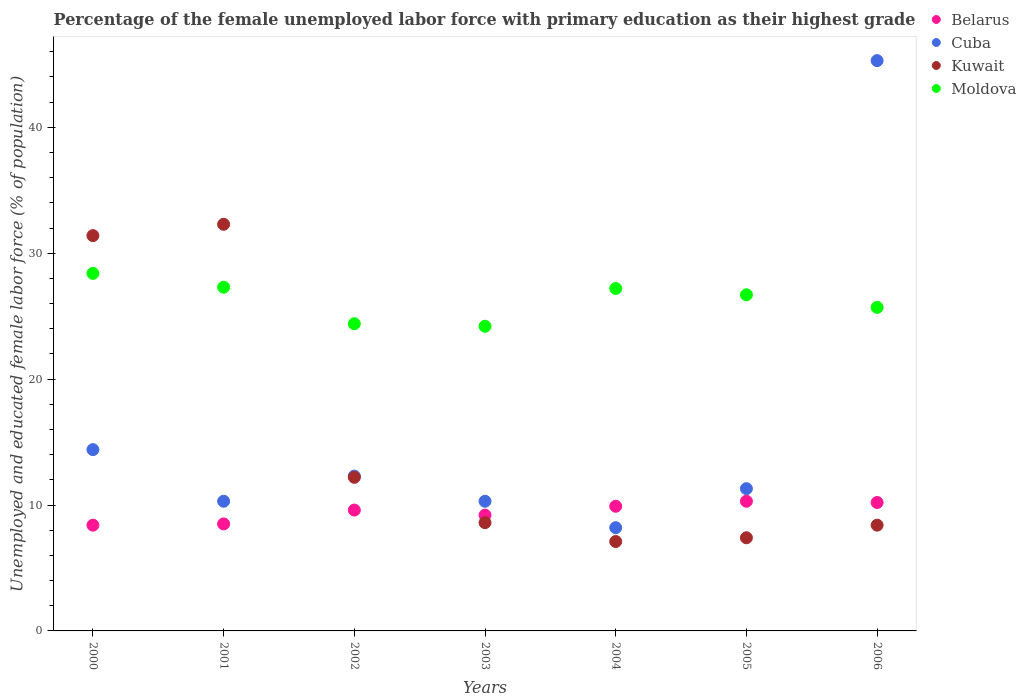How many different coloured dotlines are there?
Make the answer very short. 4. What is the percentage of the unemployed female labor force with primary education in Moldova in 2006?
Keep it short and to the point. 25.7. Across all years, what is the maximum percentage of the unemployed female labor force with primary education in Belarus?
Ensure brevity in your answer.  10.3. Across all years, what is the minimum percentage of the unemployed female labor force with primary education in Moldova?
Ensure brevity in your answer.  24.2. What is the total percentage of the unemployed female labor force with primary education in Belarus in the graph?
Ensure brevity in your answer.  66.1. What is the difference between the percentage of the unemployed female labor force with primary education in Kuwait in 2003 and that in 2004?
Ensure brevity in your answer.  1.5. What is the difference between the percentage of the unemployed female labor force with primary education in Kuwait in 2001 and the percentage of the unemployed female labor force with primary education in Belarus in 2000?
Keep it short and to the point. 23.9. What is the average percentage of the unemployed female labor force with primary education in Belarus per year?
Provide a short and direct response. 9.44. In the year 2006, what is the difference between the percentage of the unemployed female labor force with primary education in Kuwait and percentage of the unemployed female labor force with primary education in Moldova?
Your response must be concise. -17.3. What is the ratio of the percentage of the unemployed female labor force with primary education in Belarus in 2000 to that in 2002?
Your answer should be very brief. 0.87. What is the difference between the highest and the second highest percentage of the unemployed female labor force with primary education in Kuwait?
Ensure brevity in your answer.  0.9. What is the difference between the highest and the lowest percentage of the unemployed female labor force with primary education in Cuba?
Keep it short and to the point. 37.1. In how many years, is the percentage of the unemployed female labor force with primary education in Belarus greater than the average percentage of the unemployed female labor force with primary education in Belarus taken over all years?
Provide a short and direct response. 4. Does the percentage of the unemployed female labor force with primary education in Cuba monotonically increase over the years?
Make the answer very short. No. Is the percentage of the unemployed female labor force with primary education in Cuba strictly greater than the percentage of the unemployed female labor force with primary education in Moldova over the years?
Provide a succinct answer. No. Is the percentage of the unemployed female labor force with primary education in Belarus strictly less than the percentage of the unemployed female labor force with primary education in Moldova over the years?
Provide a succinct answer. Yes. How many dotlines are there?
Keep it short and to the point. 4. How many legend labels are there?
Your answer should be compact. 4. How are the legend labels stacked?
Ensure brevity in your answer.  Vertical. What is the title of the graph?
Provide a short and direct response. Percentage of the female unemployed labor force with primary education as their highest grade. Does "Mauritania" appear as one of the legend labels in the graph?
Give a very brief answer. No. What is the label or title of the X-axis?
Keep it short and to the point. Years. What is the label or title of the Y-axis?
Offer a terse response. Unemployed and educated female labor force (% of population). What is the Unemployed and educated female labor force (% of population) in Belarus in 2000?
Your answer should be very brief. 8.4. What is the Unemployed and educated female labor force (% of population) of Cuba in 2000?
Offer a very short reply. 14.4. What is the Unemployed and educated female labor force (% of population) in Kuwait in 2000?
Give a very brief answer. 31.4. What is the Unemployed and educated female labor force (% of population) in Moldova in 2000?
Ensure brevity in your answer.  28.4. What is the Unemployed and educated female labor force (% of population) in Cuba in 2001?
Provide a succinct answer. 10.3. What is the Unemployed and educated female labor force (% of population) of Kuwait in 2001?
Make the answer very short. 32.3. What is the Unemployed and educated female labor force (% of population) of Moldova in 2001?
Provide a short and direct response. 27.3. What is the Unemployed and educated female labor force (% of population) in Belarus in 2002?
Offer a terse response. 9.6. What is the Unemployed and educated female labor force (% of population) of Cuba in 2002?
Your response must be concise. 12.3. What is the Unemployed and educated female labor force (% of population) of Kuwait in 2002?
Your response must be concise. 12.2. What is the Unemployed and educated female labor force (% of population) in Moldova in 2002?
Keep it short and to the point. 24.4. What is the Unemployed and educated female labor force (% of population) of Belarus in 2003?
Offer a terse response. 9.2. What is the Unemployed and educated female labor force (% of population) of Cuba in 2003?
Your answer should be compact. 10.3. What is the Unemployed and educated female labor force (% of population) of Kuwait in 2003?
Offer a very short reply. 8.6. What is the Unemployed and educated female labor force (% of population) in Moldova in 2003?
Make the answer very short. 24.2. What is the Unemployed and educated female labor force (% of population) in Belarus in 2004?
Provide a succinct answer. 9.9. What is the Unemployed and educated female labor force (% of population) in Cuba in 2004?
Your answer should be compact. 8.2. What is the Unemployed and educated female labor force (% of population) in Kuwait in 2004?
Your answer should be compact. 7.1. What is the Unemployed and educated female labor force (% of population) of Moldova in 2004?
Ensure brevity in your answer.  27.2. What is the Unemployed and educated female labor force (% of population) in Belarus in 2005?
Offer a terse response. 10.3. What is the Unemployed and educated female labor force (% of population) of Cuba in 2005?
Ensure brevity in your answer.  11.3. What is the Unemployed and educated female labor force (% of population) in Kuwait in 2005?
Your answer should be compact. 7.4. What is the Unemployed and educated female labor force (% of population) of Moldova in 2005?
Your answer should be very brief. 26.7. What is the Unemployed and educated female labor force (% of population) in Belarus in 2006?
Offer a terse response. 10.2. What is the Unemployed and educated female labor force (% of population) of Cuba in 2006?
Make the answer very short. 45.3. What is the Unemployed and educated female labor force (% of population) of Kuwait in 2006?
Offer a very short reply. 8.4. What is the Unemployed and educated female labor force (% of population) of Moldova in 2006?
Provide a succinct answer. 25.7. Across all years, what is the maximum Unemployed and educated female labor force (% of population) of Belarus?
Your answer should be very brief. 10.3. Across all years, what is the maximum Unemployed and educated female labor force (% of population) in Cuba?
Make the answer very short. 45.3. Across all years, what is the maximum Unemployed and educated female labor force (% of population) in Kuwait?
Provide a short and direct response. 32.3. Across all years, what is the maximum Unemployed and educated female labor force (% of population) in Moldova?
Ensure brevity in your answer.  28.4. Across all years, what is the minimum Unemployed and educated female labor force (% of population) of Belarus?
Your answer should be compact. 8.4. Across all years, what is the minimum Unemployed and educated female labor force (% of population) in Cuba?
Your answer should be very brief. 8.2. Across all years, what is the minimum Unemployed and educated female labor force (% of population) of Kuwait?
Offer a terse response. 7.1. Across all years, what is the minimum Unemployed and educated female labor force (% of population) of Moldova?
Give a very brief answer. 24.2. What is the total Unemployed and educated female labor force (% of population) of Belarus in the graph?
Make the answer very short. 66.1. What is the total Unemployed and educated female labor force (% of population) of Cuba in the graph?
Provide a succinct answer. 112.1. What is the total Unemployed and educated female labor force (% of population) in Kuwait in the graph?
Ensure brevity in your answer.  107.4. What is the total Unemployed and educated female labor force (% of population) in Moldova in the graph?
Make the answer very short. 183.9. What is the difference between the Unemployed and educated female labor force (% of population) in Kuwait in 2000 and that in 2001?
Make the answer very short. -0.9. What is the difference between the Unemployed and educated female labor force (% of population) in Cuba in 2000 and that in 2002?
Keep it short and to the point. 2.1. What is the difference between the Unemployed and educated female labor force (% of population) in Moldova in 2000 and that in 2002?
Keep it short and to the point. 4. What is the difference between the Unemployed and educated female labor force (% of population) of Belarus in 2000 and that in 2003?
Keep it short and to the point. -0.8. What is the difference between the Unemployed and educated female labor force (% of population) of Kuwait in 2000 and that in 2003?
Your answer should be compact. 22.8. What is the difference between the Unemployed and educated female labor force (% of population) in Cuba in 2000 and that in 2004?
Provide a short and direct response. 6.2. What is the difference between the Unemployed and educated female labor force (% of population) in Kuwait in 2000 and that in 2004?
Give a very brief answer. 24.3. What is the difference between the Unemployed and educated female labor force (% of population) of Belarus in 2000 and that in 2005?
Your answer should be compact. -1.9. What is the difference between the Unemployed and educated female labor force (% of population) in Cuba in 2000 and that in 2005?
Offer a terse response. 3.1. What is the difference between the Unemployed and educated female labor force (% of population) in Cuba in 2000 and that in 2006?
Provide a short and direct response. -30.9. What is the difference between the Unemployed and educated female labor force (% of population) of Belarus in 2001 and that in 2002?
Give a very brief answer. -1.1. What is the difference between the Unemployed and educated female labor force (% of population) of Cuba in 2001 and that in 2002?
Provide a short and direct response. -2. What is the difference between the Unemployed and educated female labor force (% of population) in Kuwait in 2001 and that in 2002?
Give a very brief answer. 20.1. What is the difference between the Unemployed and educated female labor force (% of population) in Moldova in 2001 and that in 2002?
Provide a short and direct response. 2.9. What is the difference between the Unemployed and educated female labor force (% of population) in Belarus in 2001 and that in 2003?
Make the answer very short. -0.7. What is the difference between the Unemployed and educated female labor force (% of population) in Kuwait in 2001 and that in 2003?
Provide a succinct answer. 23.7. What is the difference between the Unemployed and educated female labor force (% of population) in Moldova in 2001 and that in 2003?
Give a very brief answer. 3.1. What is the difference between the Unemployed and educated female labor force (% of population) in Belarus in 2001 and that in 2004?
Make the answer very short. -1.4. What is the difference between the Unemployed and educated female labor force (% of population) in Cuba in 2001 and that in 2004?
Offer a terse response. 2.1. What is the difference between the Unemployed and educated female labor force (% of population) of Kuwait in 2001 and that in 2004?
Provide a succinct answer. 25.2. What is the difference between the Unemployed and educated female labor force (% of population) of Belarus in 2001 and that in 2005?
Offer a terse response. -1.8. What is the difference between the Unemployed and educated female labor force (% of population) in Kuwait in 2001 and that in 2005?
Ensure brevity in your answer.  24.9. What is the difference between the Unemployed and educated female labor force (% of population) in Moldova in 2001 and that in 2005?
Provide a succinct answer. 0.6. What is the difference between the Unemployed and educated female labor force (% of population) in Belarus in 2001 and that in 2006?
Ensure brevity in your answer.  -1.7. What is the difference between the Unemployed and educated female labor force (% of population) in Cuba in 2001 and that in 2006?
Provide a succinct answer. -35. What is the difference between the Unemployed and educated female labor force (% of population) in Kuwait in 2001 and that in 2006?
Keep it short and to the point. 23.9. What is the difference between the Unemployed and educated female labor force (% of population) of Moldova in 2001 and that in 2006?
Provide a short and direct response. 1.6. What is the difference between the Unemployed and educated female labor force (% of population) in Belarus in 2002 and that in 2003?
Keep it short and to the point. 0.4. What is the difference between the Unemployed and educated female labor force (% of population) of Cuba in 2002 and that in 2003?
Give a very brief answer. 2. What is the difference between the Unemployed and educated female labor force (% of population) in Cuba in 2002 and that in 2004?
Offer a very short reply. 4.1. What is the difference between the Unemployed and educated female labor force (% of population) in Belarus in 2002 and that in 2005?
Your response must be concise. -0.7. What is the difference between the Unemployed and educated female labor force (% of population) in Moldova in 2002 and that in 2005?
Provide a succinct answer. -2.3. What is the difference between the Unemployed and educated female labor force (% of population) in Belarus in 2002 and that in 2006?
Give a very brief answer. -0.6. What is the difference between the Unemployed and educated female labor force (% of population) of Cuba in 2002 and that in 2006?
Provide a succinct answer. -33. What is the difference between the Unemployed and educated female labor force (% of population) of Cuba in 2003 and that in 2004?
Provide a succinct answer. 2.1. What is the difference between the Unemployed and educated female labor force (% of population) of Belarus in 2003 and that in 2005?
Give a very brief answer. -1.1. What is the difference between the Unemployed and educated female labor force (% of population) of Kuwait in 2003 and that in 2005?
Offer a very short reply. 1.2. What is the difference between the Unemployed and educated female labor force (% of population) of Belarus in 2003 and that in 2006?
Keep it short and to the point. -1. What is the difference between the Unemployed and educated female labor force (% of population) in Cuba in 2003 and that in 2006?
Your response must be concise. -35. What is the difference between the Unemployed and educated female labor force (% of population) in Kuwait in 2003 and that in 2006?
Provide a short and direct response. 0.2. What is the difference between the Unemployed and educated female labor force (% of population) in Cuba in 2004 and that in 2005?
Provide a short and direct response. -3.1. What is the difference between the Unemployed and educated female labor force (% of population) in Kuwait in 2004 and that in 2005?
Keep it short and to the point. -0.3. What is the difference between the Unemployed and educated female labor force (% of population) in Cuba in 2004 and that in 2006?
Your response must be concise. -37.1. What is the difference between the Unemployed and educated female labor force (% of population) in Cuba in 2005 and that in 2006?
Make the answer very short. -34. What is the difference between the Unemployed and educated female labor force (% of population) of Kuwait in 2005 and that in 2006?
Your response must be concise. -1. What is the difference between the Unemployed and educated female labor force (% of population) in Belarus in 2000 and the Unemployed and educated female labor force (% of population) in Kuwait in 2001?
Make the answer very short. -23.9. What is the difference between the Unemployed and educated female labor force (% of population) in Belarus in 2000 and the Unemployed and educated female labor force (% of population) in Moldova in 2001?
Keep it short and to the point. -18.9. What is the difference between the Unemployed and educated female labor force (% of population) of Cuba in 2000 and the Unemployed and educated female labor force (% of population) of Kuwait in 2001?
Keep it short and to the point. -17.9. What is the difference between the Unemployed and educated female labor force (% of population) of Kuwait in 2000 and the Unemployed and educated female labor force (% of population) of Moldova in 2001?
Offer a very short reply. 4.1. What is the difference between the Unemployed and educated female labor force (% of population) in Belarus in 2000 and the Unemployed and educated female labor force (% of population) in Cuba in 2002?
Provide a succinct answer. -3.9. What is the difference between the Unemployed and educated female labor force (% of population) of Belarus in 2000 and the Unemployed and educated female labor force (% of population) of Kuwait in 2002?
Keep it short and to the point. -3.8. What is the difference between the Unemployed and educated female labor force (% of population) of Belarus in 2000 and the Unemployed and educated female labor force (% of population) of Cuba in 2003?
Provide a succinct answer. -1.9. What is the difference between the Unemployed and educated female labor force (% of population) in Belarus in 2000 and the Unemployed and educated female labor force (% of population) in Moldova in 2003?
Your answer should be compact. -15.8. What is the difference between the Unemployed and educated female labor force (% of population) of Cuba in 2000 and the Unemployed and educated female labor force (% of population) of Kuwait in 2003?
Offer a very short reply. 5.8. What is the difference between the Unemployed and educated female labor force (% of population) of Belarus in 2000 and the Unemployed and educated female labor force (% of population) of Cuba in 2004?
Give a very brief answer. 0.2. What is the difference between the Unemployed and educated female labor force (% of population) in Belarus in 2000 and the Unemployed and educated female labor force (% of population) in Kuwait in 2004?
Your answer should be compact. 1.3. What is the difference between the Unemployed and educated female labor force (% of population) in Belarus in 2000 and the Unemployed and educated female labor force (% of population) in Moldova in 2004?
Your answer should be compact. -18.8. What is the difference between the Unemployed and educated female labor force (% of population) in Cuba in 2000 and the Unemployed and educated female labor force (% of population) in Kuwait in 2004?
Make the answer very short. 7.3. What is the difference between the Unemployed and educated female labor force (% of population) in Belarus in 2000 and the Unemployed and educated female labor force (% of population) in Moldova in 2005?
Keep it short and to the point. -18.3. What is the difference between the Unemployed and educated female labor force (% of population) of Cuba in 2000 and the Unemployed and educated female labor force (% of population) of Kuwait in 2005?
Provide a succinct answer. 7. What is the difference between the Unemployed and educated female labor force (% of population) in Kuwait in 2000 and the Unemployed and educated female labor force (% of population) in Moldova in 2005?
Provide a succinct answer. 4.7. What is the difference between the Unemployed and educated female labor force (% of population) in Belarus in 2000 and the Unemployed and educated female labor force (% of population) in Cuba in 2006?
Your answer should be very brief. -36.9. What is the difference between the Unemployed and educated female labor force (% of population) in Belarus in 2000 and the Unemployed and educated female labor force (% of population) in Kuwait in 2006?
Your answer should be compact. 0. What is the difference between the Unemployed and educated female labor force (% of population) of Belarus in 2000 and the Unemployed and educated female labor force (% of population) of Moldova in 2006?
Offer a very short reply. -17.3. What is the difference between the Unemployed and educated female labor force (% of population) of Belarus in 2001 and the Unemployed and educated female labor force (% of population) of Cuba in 2002?
Make the answer very short. -3.8. What is the difference between the Unemployed and educated female labor force (% of population) of Belarus in 2001 and the Unemployed and educated female labor force (% of population) of Moldova in 2002?
Provide a succinct answer. -15.9. What is the difference between the Unemployed and educated female labor force (% of population) of Cuba in 2001 and the Unemployed and educated female labor force (% of population) of Moldova in 2002?
Make the answer very short. -14.1. What is the difference between the Unemployed and educated female labor force (% of population) of Belarus in 2001 and the Unemployed and educated female labor force (% of population) of Moldova in 2003?
Ensure brevity in your answer.  -15.7. What is the difference between the Unemployed and educated female labor force (% of population) in Cuba in 2001 and the Unemployed and educated female labor force (% of population) in Kuwait in 2003?
Offer a very short reply. 1.7. What is the difference between the Unemployed and educated female labor force (% of population) of Kuwait in 2001 and the Unemployed and educated female labor force (% of population) of Moldova in 2003?
Your answer should be very brief. 8.1. What is the difference between the Unemployed and educated female labor force (% of population) in Belarus in 2001 and the Unemployed and educated female labor force (% of population) in Kuwait in 2004?
Offer a very short reply. 1.4. What is the difference between the Unemployed and educated female labor force (% of population) in Belarus in 2001 and the Unemployed and educated female labor force (% of population) in Moldova in 2004?
Offer a very short reply. -18.7. What is the difference between the Unemployed and educated female labor force (% of population) in Cuba in 2001 and the Unemployed and educated female labor force (% of population) in Kuwait in 2004?
Give a very brief answer. 3.2. What is the difference between the Unemployed and educated female labor force (% of population) of Cuba in 2001 and the Unemployed and educated female labor force (% of population) of Moldova in 2004?
Make the answer very short. -16.9. What is the difference between the Unemployed and educated female labor force (% of population) in Belarus in 2001 and the Unemployed and educated female labor force (% of population) in Kuwait in 2005?
Give a very brief answer. 1.1. What is the difference between the Unemployed and educated female labor force (% of population) in Belarus in 2001 and the Unemployed and educated female labor force (% of population) in Moldova in 2005?
Make the answer very short. -18.2. What is the difference between the Unemployed and educated female labor force (% of population) in Cuba in 2001 and the Unemployed and educated female labor force (% of population) in Moldova in 2005?
Provide a succinct answer. -16.4. What is the difference between the Unemployed and educated female labor force (% of population) in Kuwait in 2001 and the Unemployed and educated female labor force (% of population) in Moldova in 2005?
Give a very brief answer. 5.6. What is the difference between the Unemployed and educated female labor force (% of population) of Belarus in 2001 and the Unemployed and educated female labor force (% of population) of Cuba in 2006?
Your response must be concise. -36.8. What is the difference between the Unemployed and educated female labor force (% of population) of Belarus in 2001 and the Unemployed and educated female labor force (% of population) of Moldova in 2006?
Give a very brief answer. -17.2. What is the difference between the Unemployed and educated female labor force (% of population) in Cuba in 2001 and the Unemployed and educated female labor force (% of population) in Kuwait in 2006?
Your answer should be compact. 1.9. What is the difference between the Unemployed and educated female labor force (% of population) of Cuba in 2001 and the Unemployed and educated female labor force (% of population) of Moldova in 2006?
Provide a succinct answer. -15.4. What is the difference between the Unemployed and educated female labor force (% of population) in Kuwait in 2001 and the Unemployed and educated female labor force (% of population) in Moldova in 2006?
Offer a terse response. 6.6. What is the difference between the Unemployed and educated female labor force (% of population) in Belarus in 2002 and the Unemployed and educated female labor force (% of population) in Moldova in 2003?
Provide a short and direct response. -14.6. What is the difference between the Unemployed and educated female labor force (% of population) of Cuba in 2002 and the Unemployed and educated female labor force (% of population) of Kuwait in 2003?
Ensure brevity in your answer.  3.7. What is the difference between the Unemployed and educated female labor force (% of population) of Belarus in 2002 and the Unemployed and educated female labor force (% of population) of Moldova in 2004?
Keep it short and to the point. -17.6. What is the difference between the Unemployed and educated female labor force (% of population) in Cuba in 2002 and the Unemployed and educated female labor force (% of population) in Moldova in 2004?
Provide a short and direct response. -14.9. What is the difference between the Unemployed and educated female labor force (% of population) in Kuwait in 2002 and the Unemployed and educated female labor force (% of population) in Moldova in 2004?
Your answer should be very brief. -15. What is the difference between the Unemployed and educated female labor force (% of population) of Belarus in 2002 and the Unemployed and educated female labor force (% of population) of Kuwait in 2005?
Your response must be concise. 2.2. What is the difference between the Unemployed and educated female labor force (% of population) in Belarus in 2002 and the Unemployed and educated female labor force (% of population) in Moldova in 2005?
Offer a very short reply. -17.1. What is the difference between the Unemployed and educated female labor force (% of population) in Cuba in 2002 and the Unemployed and educated female labor force (% of population) in Moldova in 2005?
Your answer should be compact. -14.4. What is the difference between the Unemployed and educated female labor force (% of population) in Belarus in 2002 and the Unemployed and educated female labor force (% of population) in Cuba in 2006?
Give a very brief answer. -35.7. What is the difference between the Unemployed and educated female labor force (% of population) in Belarus in 2002 and the Unemployed and educated female labor force (% of population) in Moldova in 2006?
Ensure brevity in your answer.  -16.1. What is the difference between the Unemployed and educated female labor force (% of population) in Cuba in 2002 and the Unemployed and educated female labor force (% of population) in Kuwait in 2006?
Give a very brief answer. 3.9. What is the difference between the Unemployed and educated female labor force (% of population) of Cuba in 2002 and the Unemployed and educated female labor force (% of population) of Moldova in 2006?
Ensure brevity in your answer.  -13.4. What is the difference between the Unemployed and educated female labor force (% of population) in Kuwait in 2002 and the Unemployed and educated female labor force (% of population) in Moldova in 2006?
Make the answer very short. -13.5. What is the difference between the Unemployed and educated female labor force (% of population) in Cuba in 2003 and the Unemployed and educated female labor force (% of population) in Kuwait in 2004?
Offer a very short reply. 3.2. What is the difference between the Unemployed and educated female labor force (% of population) in Cuba in 2003 and the Unemployed and educated female labor force (% of population) in Moldova in 2004?
Your answer should be very brief. -16.9. What is the difference between the Unemployed and educated female labor force (% of population) of Kuwait in 2003 and the Unemployed and educated female labor force (% of population) of Moldova in 2004?
Offer a very short reply. -18.6. What is the difference between the Unemployed and educated female labor force (% of population) of Belarus in 2003 and the Unemployed and educated female labor force (% of population) of Kuwait in 2005?
Provide a succinct answer. 1.8. What is the difference between the Unemployed and educated female labor force (% of population) of Belarus in 2003 and the Unemployed and educated female labor force (% of population) of Moldova in 2005?
Provide a short and direct response. -17.5. What is the difference between the Unemployed and educated female labor force (% of population) of Cuba in 2003 and the Unemployed and educated female labor force (% of population) of Moldova in 2005?
Provide a short and direct response. -16.4. What is the difference between the Unemployed and educated female labor force (% of population) of Kuwait in 2003 and the Unemployed and educated female labor force (% of population) of Moldova in 2005?
Offer a terse response. -18.1. What is the difference between the Unemployed and educated female labor force (% of population) in Belarus in 2003 and the Unemployed and educated female labor force (% of population) in Cuba in 2006?
Your response must be concise. -36.1. What is the difference between the Unemployed and educated female labor force (% of population) of Belarus in 2003 and the Unemployed and educated female labor force (% of population) of Moldova in 2006?
Offer a terse response. -16.5. What is the difference between the Unemployed and educated female labor force (% of population) of Cuba in 2003 and the Unemployed and educated female labor force (% of population) of Moldova in 2006?
Your response must be concise. -15.4. What is the difference between the Unemployed and educated female labor force (% of population) in Kuwait in 2003 and the Unemployed and educated female labor force (% of population) in Moldova in 2006?
Make the answer very short. -17.1. What is the difference between the Unemployed and educated female labor force (% of population) in Belarus in 2004 and the Unemployed and educated female labor force (% of population) in Cuba in 2005?
Keep it short and to the point. -1.4. What is the difference between the Unemployed and educated female labor force (% of population) of Belarus in 2004 and the Unemployed and educated female labor force (% of population) of Kuwait in 2005?
Keep it short and to the point. 2.5. What is the difference between the Unemployed and educated female labor force (% of population) in Belarus in 2004 and the Unemployed and educated female labor force (% of population) in Moldova in 2005?
Offer a terse response. -16.8. What is the difference between the Unemployed and educated female labor force (% of population) of Cuba in 2004 and the Unemployed and educated female labor force (% of population) of Moldova in 2005?
Give a very brief answer. -18.5. What is the difference between the Unemployed and educated female labor force (% of population) of Kuwait in 2004 and the Unemployed and educated female labor force (% of population) of Moldova in 2005?
Your response must be concise. -19.6. What is the difference between the Unemployed and educated female labor force (% of population) of Belarus in 2004 and the Unemployed and educated female labor force (% of population) of Cuba in 2006?
Provide a succinct answer. -35.4. What is the difference between the Unemployed and educated female labor force (% of population) of Belarus in 2004 and the Unemployed and educated female labor force (% of population) of Kuwait in 2006?
Keep it short and to the point. 1.5. What is the difference between the Unemployed and educated female labor force (% of population) in Belarus in 2004 and the Unemployed and educated female labor force (% of population) in Moldova in 2006?
Provide a short and direct response. -15.8. What is the difference between the Unemployed and educated female labor force (% of population) of Cuba in 2004 and the Unemployed and educated female labor force (% of population) of Kuwait in 2006?
Provide a short and direct response. -0.2. What is the difference between the Unemployed and educated female labor force (% of population) of Cuba in 2004 and the Unemployed and educated female labor force (% of population) of Moldova in 2006?
Keep it short and to the point. -17.5. What is the difference between the Unemployed and educated female labor force (% of population) in Kuwait in 2004 and the Unemployed and educated female labor force (% of population) in Moldova in 2006?
Provide a short and direct response. -18.6. What is the difference between the Unemployed and educated female labor force (% of population) in Belarus in 2005 and the Unemployed and educated female labor force (% of population) in Cuba in 2006?
Offer a very short reply. -35. What is the difference between the Unemployed and educated female labor force (% of population) in Belarus in 2005 and the Unemployed and educated female labor force (% of population) in Moldova in 2006?
Your response must be concise. -15.4. What is the difference between the Unemployed and educated female labor force (% of population) of Cuba in 2005 and the Unemployed and educated female labor force (% of population) of Kuwait in 2006?
Provide a succinct answer. 2.9. What is the difference between the Unemployed and educated female labor force (% of population) of Cuba in 2005 and the Unemployed and educated female labor force (% of population) of Moldova in 2006?
Your answer should be compact. -14.4. What is the difference between the Unemployed and educated female labor force (% of population) of Kuwait in 2005 and the Unemployed and educated female labor force (% of population) of Moldova in 2006?
Make the answer very short. -18.3. What is the average Unemployed and educated female labor force (% of population) in Belarus per year?
Keep it short and to the point. 9.44. What is the average Unemployed and educated female labor force (% of population) in Cuba per year?
Your answer should be compact. 16.01. What is the average Unemployed and educated female labor force (% of population) in Kuwait per year?
Provide a succinct answer. 15.34. What is the average Unemployed and educated female labor force (% of population) in Moldova per year?
Offer a very short reply. 26.27. In the year 2000, what is the difference between the Unemployed and educated female labor force (% of population) in Belarus and Unemployed and educated female labor force (% of population) in Kuwait?
Your response must be concise. -23. In the year 2000, what is the difference between the Unemployed and educated female labor force (% of population) in Cuba and Unemployed and educated female labor force (% of population) in Moldova?
Keep it short and to the point. -14. In the year 2001, what is the difference between the Unemployed and educated female labor force (% of population) of Belarus and Unemployed and educated female labor force (% of population) of Kuwait?
Offer a very short reply. -23.8. In the year 2001, what is the difference between the Unemployed and educated female labor force (% of population) in Belarus and Unemployed and educated female labor force (% of population) in Moldova?
Offer a terse response. -18.8. In the year 2001, what is the difference between the Unemployed and educated female labor force (% of population) in Cuba and Unemployed and educated female labor force (% of population) in Kuwait?
Offer a terse response. -22. In the year 2002, what is the difference between the Unemployed and educated female labor force (% of population) in Belarus and Unemployed and educated female labor force (% of population) in Kuwait?
Give a very brief answer. -2.6. In the year 2002, what is the difference between the Unemployed and educated female labor force (% of population) of Belarus and Unemployed and educated female labor force (% of population) of Moldova?
Your answer should be compact. -14.8. In the year 2002, what is the difference between the Unemployed and educated female labor force (% of population) of Cuba and Unemployed and educated female labor force (% of population) of Moldova?
Provide a succinct answer. -12.1. In the year 2002, what is the difference between the Unemployed and educated female labor force (% of population) of Kuwait and Unemployed and educated female labor force (% of population) of Moldova?
Keep it short and to the point. -12.2. In the year 2003, what is the difference between the Unemployed and educated female labor force (% of population) of Belarus and Unemployed and educated female labor force (% of population) of Cuba?
Offer a very short reply. -1.1. In the year 2003, what is the difference between the Unemployed and educated female labor force (% of population) of Belarus and Unemployed and educated female labor force (% of population) of Moldova?
Ensure brevity in your answer.  -15. In the year 2003, what is the difference between the Unemployed and educated female labor force (% of population) in Cuba and Unemployed and educated female labor force (% of population) in Kuwait?
Offer a terse response. 1.7. In the year 2003, what is the difference between the Unemployed and educated female labor force (% of population) in Kuwait and Unemployed and educated female labor force (% of population) in Moldova?
Ensure brevity in your answer.  -15.6. In the year 2004, what is the difference between the Unemployed and educated female labor force (% of population) in Belarus and Unemployed and educated female labor force (% of population) in Cuba?
Make the answer very short. 1.7. In the year 2004, what is the difference between the Unemployed and educated female labor force (% of population) in Belarus and Unemployed and educated female labor force (% of population) in Moldova?
Your answer should be compact. -17.3. In the year 2004, what is the difference between the Unemployed and educated female labor force (% of population) in Cuba and Unemployed and educated female labor force (% of population) in Kuwait?
Your answer should be compact. 1.1. In the year 2004, what is the difference between the Unemployed and educated female labor force (% of population) in Cuba and Unemployed and educated female labor force (% of population) in Moldova?
Offer a terse response. -19. In the year 2004, what is the difference between the Unemployed and educated female labor force (% of population) of Kuwait and Unemployed and educated female labor force (% of population) of Moldova?
Provide a short and direct response. -20.1. In the year 2005, what is the difference between the Unemployed and educated female labor force (% of population) of Belarus and Unemployed and educated female labor force (% of population) of Moldova?
Provide a succinct answer. -16.4. In the year 2005, what is the difference between the Unemployed and educated female labor force (% of population) of Cuba and Unemployed and educated female labor force (% of population) of Kuwait?
Offer a very short reply. 3.9. In the year 2005, what is the difference between the Unemployed and educated female labor force (% of population) of Cuba and Unemployed and educated female labor force (% of population) of Moldova?
Ensure brevity in your answer.  -15.4. In the year 2005, what is the difference between the Unemployed and educated female labor force (% of population) of Kuwait and Unemployed and educated female labor force (% of population) of Moldova?
Ensure brevity in your answer.  -19.3. In the year 2006, what is the difference between the Unemployed and educated female labor force (% of population) of Belarus and Unemployed and educated female labor force (% of population) of Cuba?
Provide a short and direct response. -35.1. In the year 2006, what is the difference between the Unemployed and educated female labor force (% of population) in Belarus and Unemployed and educated female labor force (% of population) in Kuwait?
Give a very brief answer. 1.8. In the year 2006, what is the difference between the Unemployed and educated female labor force (% of population) in Belarus and Unemployed and educated female labor force (% of population) in Moldova?
Provide a succinct answer. -15.5. In the year 2006, what is the difference between the Unemployed and educated female labor force (% of population) in Cuba and Unemployed and educated female labor force (% of population) in Kuwait?
Your answer should be very brief. 36.9. In the year 2006, what is the difference between the Unemployed and educated female labor force (% of population) of Cuba and Unemployed and educated female labor force (% of population) of Moldova?
Give a very brief answer. 19.6. In the year 2006, what is the difference between the Unemployed and educated female labor force (% of population) in Kuwait and Unemployed and educated female labor force (% of population) in Moldova?
Your response must be concise. -17.3. What is the ratio of the Unemployed and educated female labor force (% of population) of Belarus in 2000 to that in 2001?
Give a very brief answer. 0.99. What is the ratio of the Unemployed and educated female labor force (% of population) of Cuba in 2000 to that in 2001?
Ensure brevity in your answer.  1.4. What is the ratio of the Unemployed and educated female labor force (% of population) of Kuwait in 2000 to that in 2001?
Your answer should be very brief. 0.97. What is the ratio of the Unemployed and educated female labor force (% of population) in Moldova in 2000 to that in 2001?
Make the answer very short. 1.04. What is the ratio of the Unemployed and educated female labor force (% of population) of Cuba in 2000 to that in 2002?
Your answer should be compact. 1.17. What is the ratio of the Unemployed and educated female labor force (% of population) in Kuwait in 2000 to that in 2002?
Provide a succinct answer. 2.57. What is the ratio of the Unemployed and educated female labor force (% of population) in Moldova in 2000 to that in 2002?
Provide a succinct answer. 1.16. What is the ratio of the Unemployed and educated female labor force (% of population) in Belarus in 2000 to that in 2003?
Keep it short and to the point. 0.91. What is the ratio of the Unemployed and educated female labor force (% of population) of Cuba in 2000 to that in 2003?
Your answer should be compact. 1.4. What is the ratio of the Unemployed and educated female labor force (% of population) of Kuwait in 2000 to that in 2003?
Your answer should be very brief. 3.65. What is the ratio of the Unemployed and educated female labor force (% of population) of Moldova in 2000 to that in 2003?
Keep it short and to the point. 1.17. What is the ratio of the Unemployed and educated female labor force (% of population) in Belarus in 2000 to that in 2004?
Your answer should be compact. 0.85. What is the ratio of the Unemployed and educated female labor force (% of population) in Cuba in 2000 to that in 2004?
Your answer should be compact. 1.76. What is the ratio of the Unemployed and educated female labor force (% of population) in Kuwait in 2000 to that in 2004?
Ensure brevity in your answer.  4.42. What is the ratio of the Unemployed and educated female labor force (% of population) of Moldova in 2000 to that in 2004?
Give a very brief answer. 1.04. What is the ratio of the Unemployed and educated female labor force (% of population) in Belarus in 2000 to that in 2005?
Keep it short and to the point. 0.82. What is the ratio of the Unemployed and educated female labor force (% of population) of Cuba in 2000 to that in 2005?
Offer a very short reply. 1.27. What is the ratio of the Unemployed and educated female labor force (% of population) in Kuwait in 2000 to that in 2005?
Your response must be concise. 4.24. What is the ratio of the Unemployed and educated female labor force (% of population) of Moldova in 2000 to that in 2005?
Your answer should be compact. 1.06. What is the ratio of the Unemployed and educated female labor force (% of population) of Belarus in 2000 to that in 2006?
Your answer should be compact. 0.82. What is the ratio of the Unemployed and educated female labor force (% of population) of Cuba in 2000 to that in 2006?
Offer a very short reply. 0.32. What is the ratio of the Unemployed and educated female labor force (% of population) of Kuwait in 2000 to that in 2006?
Provide a short and direct response. 3.74. What is the ratio of the Unemployed and educated female labor force (% of population) of Moldova in 2000 to that in 2006?
Your response must be concise. 1.11. What is the ratio of the Unemployed and educated female labor force (% of population) in Belarus in 2001 to that in 2002?
Give a very brief answer. 0.89. What is the ratio of the Unemployed and educated female labor force (% of population) of Cuba in 2001 to that in 2002?
Keep it short and to the point. 0.84. What is the ratio of the Unemployed and educated female labor force (% of population) of Kuwait in 2001 to that in 2002?
Make the answer very short. 2.65. What is the ratio of the Unemployed and educated female labor force (% of population) of Moldova in 2001 to that in 2002?
Offer a very short reply. 1.12. What is the ratio of the Unemployed and educated female labor force (% of population) of Belarus in 2001 to that in 2003?
Provide a short and direct response. 0.92. What is the ratio of the Unemployed and educated female labor force (% of population) of Kuwait in 2001 to that in 2003?
Provide a succinct answer. 3.76. What is the ratio of the Unemployed and educated female labor force (% of population) of Moldova in 2001 to that in 2003?
Provide a succinct answer. 1.13. What is the ratio of the Unemployed and educated female labor force (% of population) of Belarus in 2001 to that in 2004?
Offer a terse response. 0.86. What is the ratio of the Unemployed and educated female labor force (% of population) in Cuba in 2001 to that in 2004?
Make the answer very short. 1.26. What is the ratio of the Unemployed and educated female labor force (% of population) in Kuwait in 2001 to that in 2004?
Provide a succinct answer. 4.55. What is the ratio of the Unemployed and educated female labor force (% of population) of Belarus in 2001 to that in 2005?
Make the answer very short. 0.83. What is the ratio of the Unemployed and educated female labor force (% of population) of Cuba in 2001 to that in 2005?
Your answer should be very brief. 0.91. What is the ratio of the Unemployed and educated female labor force (% of population) in Kuwait in 2001 to that in 2005?
Keep it short and to the point. 4.36. What is the ratio of the Unemployed and educated female labor force (% of population) in Moldova in 2001 to that in 2005?
Your response must be concise. 1.02. What is the ratio of the Unemployed and educated female labor force (% of population) in Cuba in 2001 to that in 2006?
Offer a very short reply. 0.23. What is the ratio of the Unemployed and educated female labor force (% of population) of Kuwait in 2001 to that in 2006?
Make the answer very short. 3.85. What is the ratio of the Unemployed and educated female labor force (% of population) in Moldova in 2001 to that in 2006?
Provide a succinct answer. 1.06. What is the ratio of the Unemployed and educated female labor force (% of population) of Belarus in 2002 to that in 2003?
Your answer should be very brief. 1.04. What is the ratio of the Unemployed and educated female labor force (% of population) in Cuba in 2002 to that in 2003?
Make the answer very short. 1.19. What is the ratio of the Unemployed and educated female labor force (% of population) of Kuwait in 2002 to that in 2003?
Ensure brevity in your answer.  1.42. What is the ratio of the Unemployed and educated female labor force (% of population) of Moldova in 2002 to that in 2003?
Your answer should be compact. 1.01. What is the ratio of the Unemployed and educated female labor force (% of population) in Belarus in 2002 to that in 2004?
Offer a very short reply. 0.97. What is the ratio of the Unemployed and educated female labor force (% of population) of Kuwait in 2002 to that in 2004?
Make the answer very short. 1.72. What is the ratio of the Unemployed and educated female labor force (% of population) of Moldova in 2002 to that in 2004?
Provide a succinct answer. 0.9. What is the ratio of the Unemployed and educated female labor force (% of population) in Belarus in 2002 to that in 2005?
Give a very brief answer. 0.93. What is the ratio of the Unemployed and educated female labor force (% of population) in Cuba in 2002 to that in 2005?
Give a very brief answer. 1.09. What is the ratio of the Unemployed and educated female labor force (% of population) of Kuwait in 2002 to that in 2005?
Provide a short and direct response. 1.65. What is the ratio of the Unemployed and educated female labor force (% of population) in Moldova in 2002 to that in 2005?
Offer a terse response. 0.91. What is the ratio of the Unemployed and educated female labor force (% of population) of Cuba in 2002 to that in 2006?
Provide a succinct answer. 0.27. What is the ratio of the Unemployed and educated female labor force (% of population) of Kuwait in 2002 to that in 2006?
Your answer should be very brief. 1.45. What is the ratio of the Unemployed and educated female labor force (% of population) of Moldova in 2002 to that in 2006?
Your answer should be very brief. 0.95. What is the ratio of the Unemployed and educated female labor force (% of population) of Belarus in 2003 to that in 2004?
Provide a short and direct response. 0.93. What is the ratio of the Unemployed and educated female labor force (% of population) in Cuba in 2003 to that in 2004?
Offer a terse response. 1.26. What is the ratio of the Unemployed and educated female labor force (% of population) of Kuwait in 2003 to that in 2004?
Give a very brief answer. 1.21. What is the ratio of the Unemployed and educated female labor force (% of population) in Moldova in 2003 to that in 2004?
Make the answer very short. 0.89. What is the ratio of the Unemployed and educated female labor force (% of population) of Belarus in 2003 to that in 2005?
Offer a terse response. 0.89. What is the ratio of the Unemployed and educated female labor force (% of population) in Cuba in 2003 to that in 2005?
Keep it short and to the point. 0.91. What is the ratio of the Unemployed and educated female labor force (% of population) in Kuwait in 2003 to that in 2005?
Keep it short and to the point. 1.16. What is the ratio of the Unemployed and educated female labor force (% of population) of Moldova in 2003 to that in 2005?
Your answer should be very brief. 0.91. What is the ratio of the Unemployed and educated female labor force (% of population) in Belarus in 2003 to that in 2006?
Ensure brevity in your answer.  0.9. What is the ratio of the Unemployed and educated female labor force (% of population) of Cuba in 2003 to that in 2006?
Provide a succinct answer. 0.23. What is the ratio of the Unemployed and educated female labor force (% of population) of Kuwait in 2003 to that in 2006?
Provide a short and direct response. 1.02. What is the ratio of the Unemployed and educated female labor force (% of population) in Moldova in 2003 to that in 2006?
Keep it short and to the point. 0.94. What is the ratio of the Unemployed and educated female labor force (% of population) of Belarus in 2004 to that in 2005?
Keep it short and to the point. 0.96. What is the ratio of the Unemployed and educated female labor force (% of population) in Cuba in 2004 to that in 2005?
Ensure brevity in your answer.  0.73. What is the ratio of the Unemployed and educated female labor force (% of population) of Kuwait in 2004 to that in 2005?
Give a very brief answer. 0.96. What is the ratio of the Unemployed and educated female labor force (% of population) of Moldova in 2004 to that in 2005?
Offer a terse response. 1.02. What is the ratio of the Unemployed and educated female labor force (% of population) in Belarus in 2004 to that in 2006?
Your answer should be compact. 0.97. What is the ratio of the Unemployed and educated female labor force (% of population) in Cuba in 2004 to that in 2006?
Ensure brevity in your answer.  0.18. What is the ratio of the Unemployed and educated female labor force (% of population) in Kuwait in 2004 to that in 2006?
Offer a very short reply. 0.85. What is the ratio of the Unemployed and educated female labor force (% of population) of Moldova in 2004 to that in 2006?
Your answer should be compact. 1.06. What is the ratio of the Unemployed and educated female labor force (% of population) in Belarus in 2005 to that in 2006?
Your response must be concise. 1.01. What is the ratio of the Unemployed and educated female labor force (% of population) in Cuba in 2005 to that in 2006?
Keep it short and to the point. 0.25. What is the ratio of the Unemployed and educated female labor force (% of population) in Kuwait in 2005 to that in 2006?
Offer a very short reply. 0.88. What is the ratio of the Unemployed and educated female labor force (% of population) in Moldova in 2005 to that in 2006?
Offer a very short reply. 1.04. What is the difference between the highest and the second highest Unemployed and educated female labor force (% of population) of Cuba?
Give a very brief answer. 30.9. What is the difference between the highest and the lowest Unemployed and educated female labor force (% of population) of Belarus?
Your response must be concise. 1.9. What is the difference between the highest and the lowest Unemployed and educated female labor force (% of population) of Cuba?
Keep it short and to the point. 37.1. What is the difference between the highest and the lowest Unemployed and educated female labor force (% of population) in Kuwait?
Offer a very short reply. 25.2. 